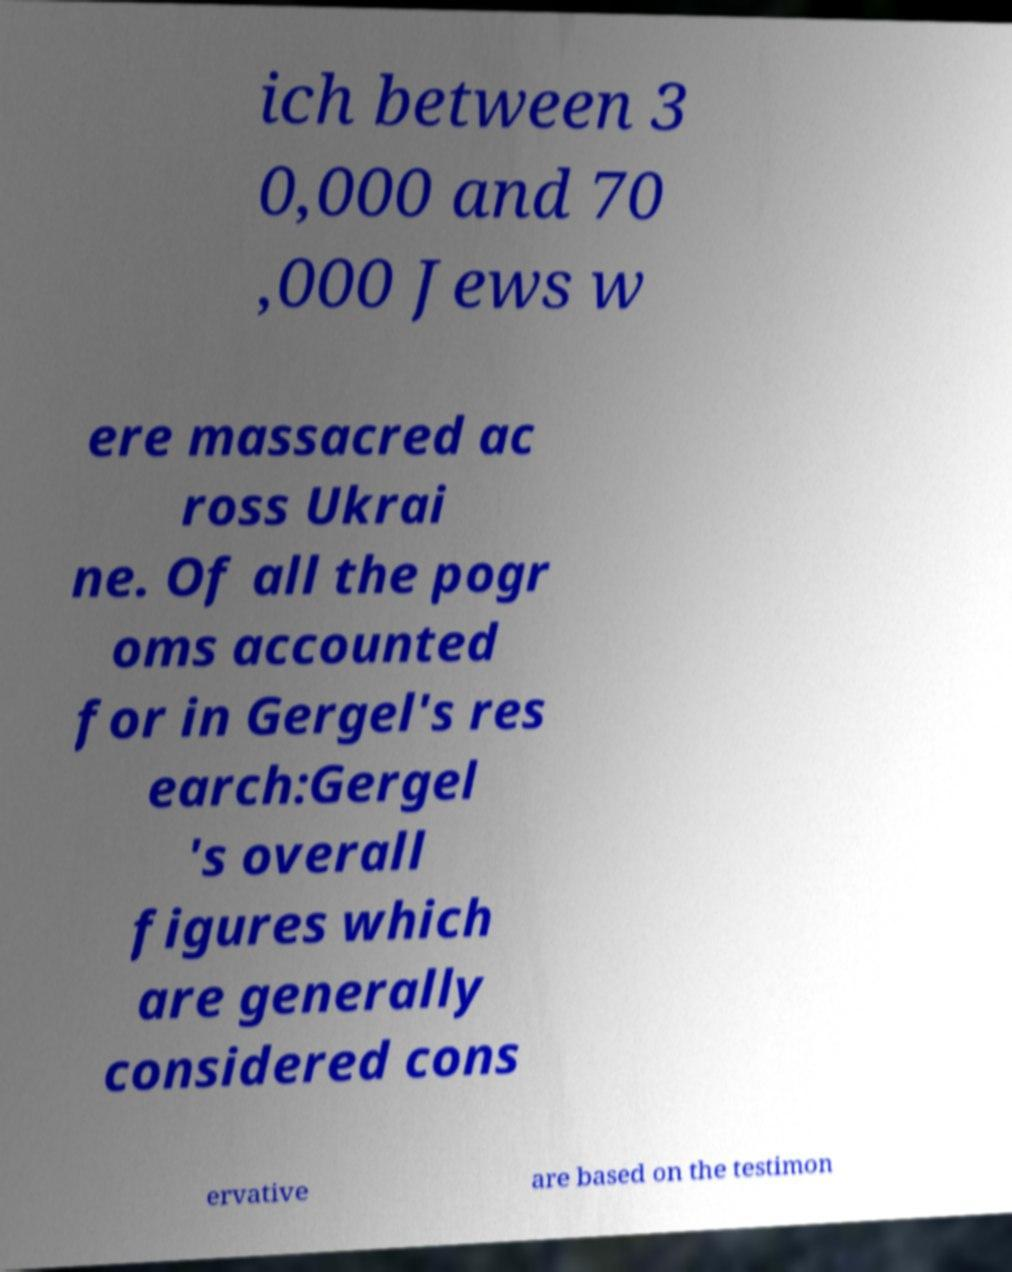What messages or text are displayed in this image? I need them in a readable, typed format. ich between 3 0,000 and 70 ,000 Jews w ere massacred ac ross Ukrai ne. Of all the pogr oms accounted for in Gergel's res earch:Gergel 's overall figures which are generally considered cons ervative are based on the testimon 